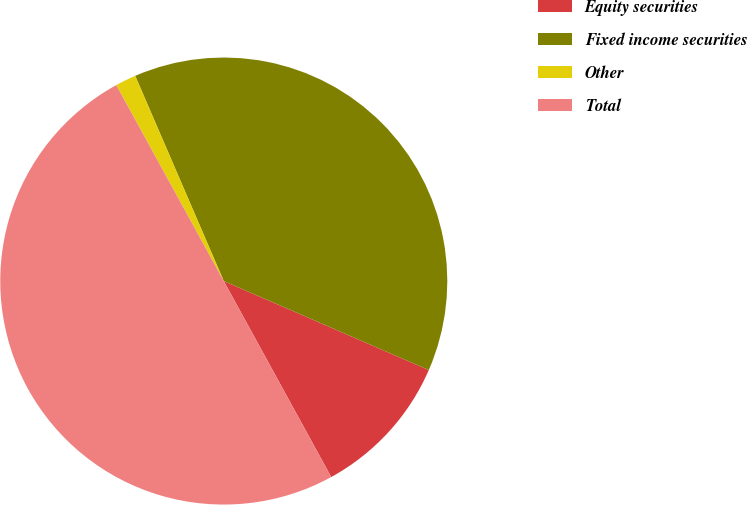Convert chart to OTSL. <chart><loc_0><loc_0><loc_500><loc_500><pie_chart><fcel>Equity securities<fcel>Fixed income securities<fcel>Other<fcel>Total<nl><fcel>10.5%<fcel>38.0%<fcel>1.5%<fcel>50.0%<nl></chart> 